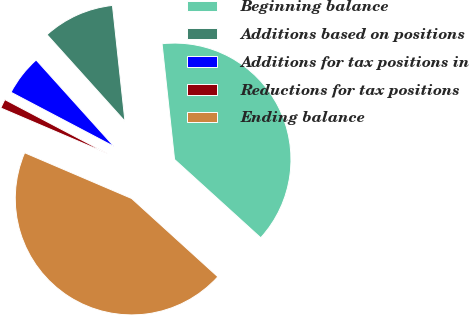Convert chart to OTSL. <chart><loc_0><loc_0><loc_500><loc_500><pie_chart><fcel>Beginning balance<fcel>Additions based on positions<fcel>Additions for tax positions in<fcel>Reductions for tax positions<fcel>Ending balance<nl><fcel>38.45%<fcel>9.96%<fcel>5.62%<fcel>1.28%<fcel>44.7%<nl></chart> 